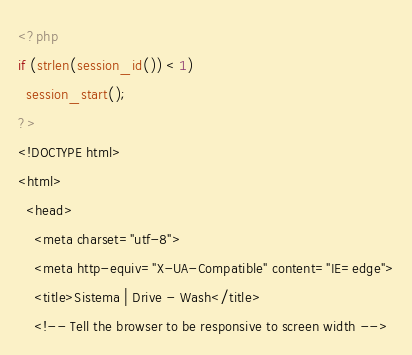Convert code to text. <code><loc_0><loc_0><loc_500><loc_500><_PHP_><?php
if (strlen(session_id()) < 1) 
  session_start();
?>
<!DOCTYPE html>
<html>
  <head>
    <meta charset="utf-8">
    <meta http-equiv="X-UA-Compatible" content="IE=edge">
    <title>Sistema | Drive - Wash</title>
    <!-- Tell the browser to be responsive to screen width --></code> 